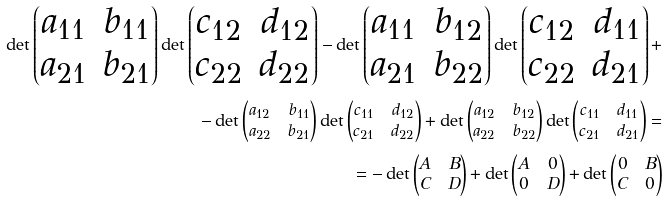Convert formula to latex. <formula><loc_0><loc_0><loc_500><loc_500>\det \begin{pmatrix} a _ { 1 1 } & b _ { 1 1 } \\ a _ { 2 1 } & b _ { 2 1 } \end{pmatrix} \det \begin{pmatrix} c _ { 1 2 } & d _ { 1 2 } \\ c _ { 2 2 } & d _ { 2 2 } \end{pmatrix} - \det \begin{pmatrix} a _ { 1 1 } & b _ { 1 2 } \\ a _ { 2 1 } & b _ { 2 2 } \end{pmatrix} \det \begin{pmatrix} c _ { 1 2 } & d _ { 1 1 } \\ c _ { 2 2 } & d _ { 2 1 } \end{pmatrix} + \\ - \det \begin{pmatrix} a _ { 1 2 } & b _ { 1 1 } \\ a _ { 2 2 } & b _ { 2 1 } \end{pmatrix} \det \begin{pmatrix} c _ { 1 1 } & d _ { 1 2 } \\ c _ { 2 1 } & d _ { 2 2 } \end{pmatrix} + \det \begin{pmatrix} a _ { 1 2 } & b _ { 1 2 } \\ a _ { 2 2 } & b _ { 2 2 } \end{pmatrix} \det \begin{pmatrix} c _ { 1 1 } & d _ { 1 1 } \\ c _ { 2 1 } & d _ { 2 1 } \end{pmatrix} = \\ = - \det \begin{pmatrix} A & B \\ C & D \end{pmatrix} + \det \begin{pmatrix} A & 0 \\ 0 & D \end{pmatrix} + \det \begin{pmatrix} 0 & B \\ C & 0 \end{pmatrix}</formula> 